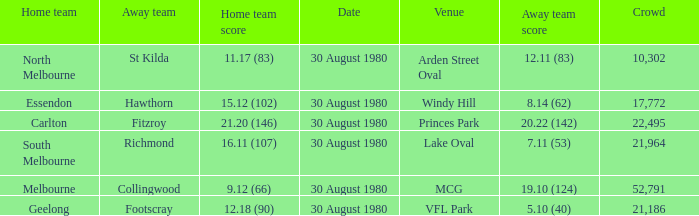What was the crowd when the away team is footscray? 21186.0. 